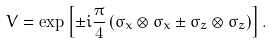Convert formula to latex. <formula><loc_0><loc_0><loc_500><loc_500>V = \exp \left [ \pm i \frac { \pi } { 4 } \left ( \sigma _ { x } \otimes \sigma _ { x } \pm \sigma _ { z } \otimes \sigma _ { z } \right ) \right ] .</formula> 